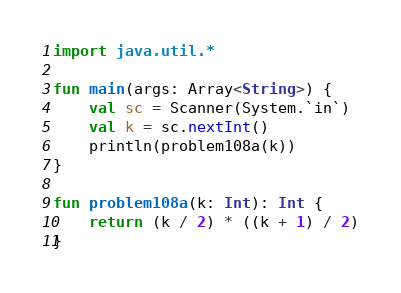Convert code to text. <code><loc_0><loc_0><loc_500><loc_500><_Kotlin_>import java.util.*

fun main(args: Array<String>) {
    val sc = Scanner(System.`in`)
    val k = sc.nextInt()
    println(problem108a(k))
}

fun problem108a(k: Int): Int {
    return (k / 2) * ((k + 1) / 2)
}</code> 